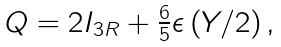Convert formula to latex. <formula><loc_0><loc_0><loc_500><loc_500>\begin{array} { c } Q = 2 I _ { 3 R } + \frac { 6 } { 5 } \epsilon \left ( Y / 2 \right ) , \end{array}</formula> 